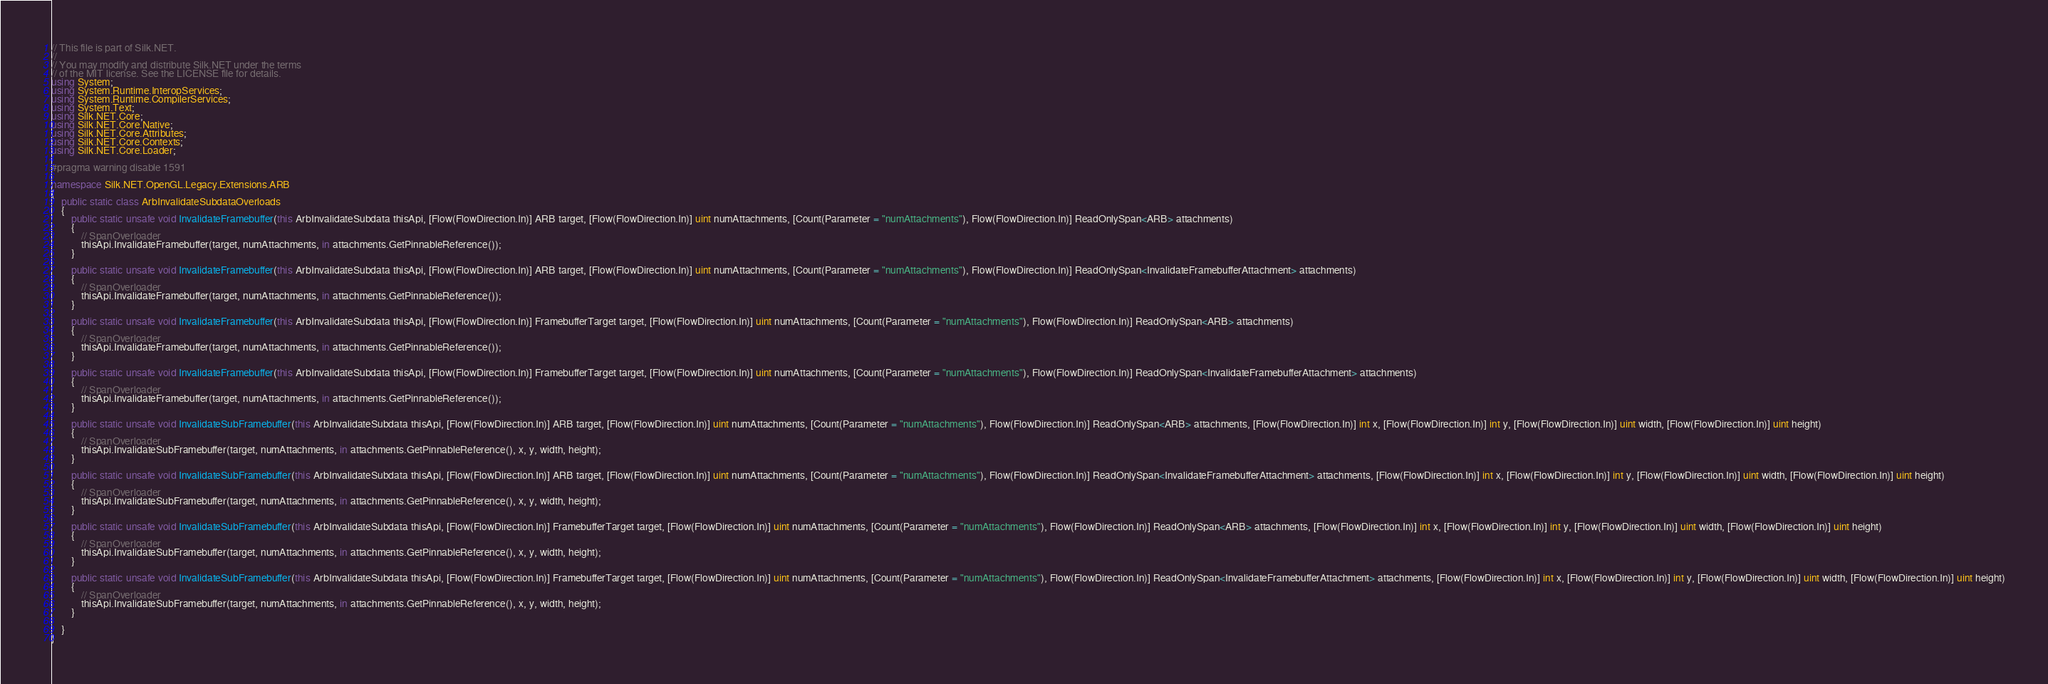Convert code to text. <code><loc_0><loc_0><loc_500><loc_500><_C#_>// This file is part of Silk.NET.
// 
// You may modify and distribute Silk.NET under the terms
// of the MIT license. See the LICENSE file for details.
using System;
using System.Runtime.InteropServices;
using System.Runtime.CompilerServices;
using System.Text;
using Silk.NET.Core;
using Silk.NET.Core.Native;
using Silk.NET.Core.Attributes;
using Silk.NET.Core.Contexts;
using Silk.NET.Core.Loader;

#pragma warning disable 1591

namespace Silk.NET.OpenGL.Legacy.Extensions.ARB
{
    public static class ArbInvalidateSubdataOverloads
    {
        public static unsafe void InvalidateFramebuffer(this ArbInvalidateSubdata thisApi, [Flow(FlowDirection.In)] ARB target, [Flow(FlowDirection.In)] uint numAttachments, [Count(Parameter = "numAttachments"), Flow(FlowDirection.In)] ReadOnlySpan<ARB> attachments)
        {
            // SpanOverloader
            thisApi.InvalidateFramebuffer(target, numAttachments, in attachments.GetPinnableReference());
        }

        public static unsafe void InvalidateFramebuffer(this ArbInvalidateSubdata thisApi, [Flow(FlowDirection.In)] ARB target, [Flow(FlowDirection.In)] uint numAttachments, [Count(Parameter = "numAttachments"), Flow(FlowDirection.In)] ReadOnlySpan<InvalidateFramebufferAttachment> attachments)
        {
            // SpanOverloader
            thisApi.InvalidateFramebuffer(target, numAttachments, in attachments.GetPinnableReference());
        }

        public static unsafe void InvalidateFramebuffer(this ArbInvalidateSubdata thisApi, [Flow(FlowDirection.In)] FramebufferTarget target, [Flow(FlowDirection.In)] uint numAttachments, [Count(Parameter = "numAttachments"), Flow(FlowDirection.In)] ReadOnlySpan<ARB> attachments)
        {
            // SpanOverloader
            thisApi.InvalidateFramebuffer(target, numAttachments, in attachments.GetPinnableReference());
        }

        public static unsafe void InvalidateFramebuffer(this ArbInvalidateSubdata thisApi, [Flow(FlowDirection.In)] FramebufferTarget target, [Flow(FlowDirection.In)] uint numAttachments, [Count(Parameter = "numAttachments"), Flow(FlowDirection.In)] ReadOnlySpan<InvalidateFramebufferAttachment> attachments)
        {
            // SpanOverloader
            thisApi.InvalidateFramebuffer(target, numAttachments, in attachments.GetPinnableReference());
        }

        public static unsafe void InvalidateSubFramebuffer(this ArbInvalidateSubdata thisApi, [Flow(FlowDirection.In)] ARB target, [Flow(FlowDirection.In)] uint numAttachments, [Count(Parameter = "numAttachments"), Flow(FlowDirection.In)] ReadOnlySpan<ARB> attachments, [Flow(FlowDirection.In)] int x, [Flow(FlowDirection.In)] int y, [Flow(FlowDirection.In)] uint width, [Flow(FlowDirection.In)] uint height)
        {
            // SpanOverloader
            thisApi.InvalidateSubFramebuffer(target, numAttachments, in attachments.GetPinnableReference(), x, y, width, height);
        }

        public static unsafe void InvalidateSubFramebuffer(this ArbInvalidateSubdata thisApi, [Flow(FlowDirection.In)] ARB target, [Flow(FlowDirection.In)] uint numAttachments, [Count(Parameter = "numAttachments"), Flow(FlowDirection.In)] ReadOnlySpan<InvalidateFramebufferAttachment> attachments, [Flow(FlowDirection.In)] int x, [Flow(FlowDirection.In)] int y, [Flow(FlowDirection.In)] uint width, [Flow(FlowDirection.In)] uint height)
        {
            // SpanOverloader
            thisApi.InvalidateSubFramebuffer(target, numAttachments, in attachments.GetPinnableReference(), x, y, width, height);
        }

        public static unsafe void InvalidateSubFramebuffer(this ArbInvalidateSubdata thisApi, [Flow(FlowDirection.In)] FramebufferTarget target, [Flow(FlowDirection.In)] uint numAttachments, [Count(Parameter = "numAttachments"), Flow(FlowDirection.In)] ReadOnlySpan<ARB> attachments, [Flow(FlowDirection.In)] int x, [Flow(FlowDirection.In)] int y, [Flow(FlowDirection.In)] uint width, [Flow(FlowDirection.In)] uint height)
        {
            // SpanOverloader
            thisApi.InvalidateSubFramebuffer(target, numAttachments, in attachments.GetPinnableReference(), x, y, width, height);
        }

        public static unsafe void InvalidateSubFramebuffer(this ArbInvalidateSubdata thisApi, [Flow(FlowDirection.In)] FramebufferTarget target, [Flow(FlowDirection.In)] uint numAttachments, [Count(Parameter = "numAttachments"), Flow(FlowDirection.In)] ReadOnlySpan<InvalidateFramebufferAttachment> attachments, [Flow(FlowDirection.In)] int x, [Flow(FlowDirection.In)] int y, [Flow(FlowDirection.In)] uint width, [Flow(FlowDirection.In)] uint height)
        {
            // SpanOverloader
            thisApi.InvalidateSubFramebuffer(target, numAttachments, in attachments.GetPinnableReference(), x, y, width, height);
        }

    }
}

</code> 